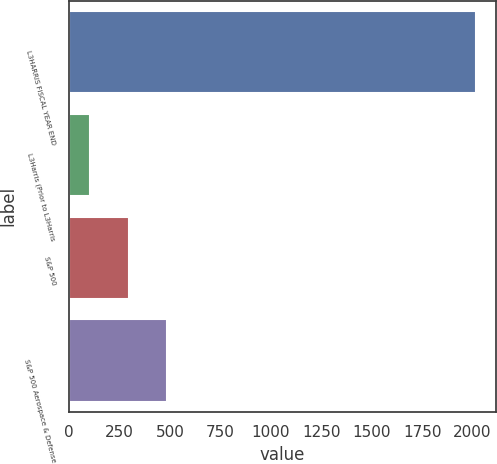Convert chart. <chart><loc_0><loc_0><loc_500><loc_500><bar_chart><fcel>L3HARRIS FISCAL YEAR END<fcel>L3Harris (Prior to L3Harris<fcel>S&P 500<fcel>S&P 500 Aerospace & Defense<nl><fcel>2015<fcel>105<fcel>296<fcel>487<nl></chart> 